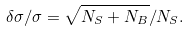Convert formula to latex. <formula><loc_0><loc_0><loc_500><loc_500>\delta \sigma / \sigma = \sqrt { N _ { S } + N _ { B } } / N _ { S } .</formula> 